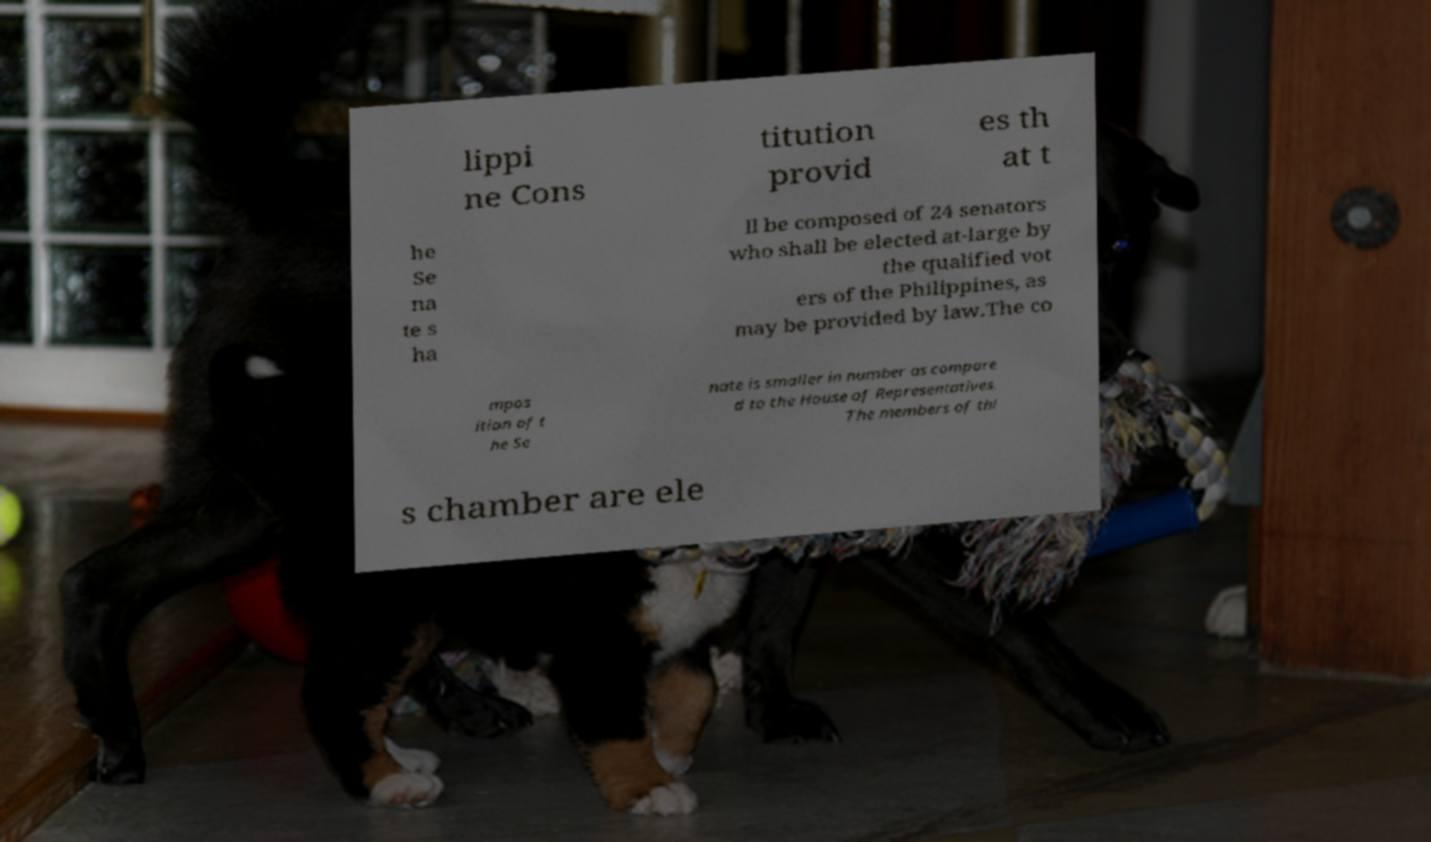There's text embedded in this image that I need extracted. Can you transcribe it verbatim? lippi ne Cons titution provid es th at t he Se na te s ha ll be composed of 24 senators who shall be elected at-large by the qualified vot ers of the Philippines, as may be provided by law.The co mpos ition of t he Se nate is smaller in number as compare d to the House of Representatives. The members of thi s chamber are ele 